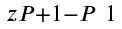<formula> <loc_0><loc_0><loc_500><loc_500>\begin{smallmatrix} z P + 1 - P & 1 \end{smallmatrix}</formula> 